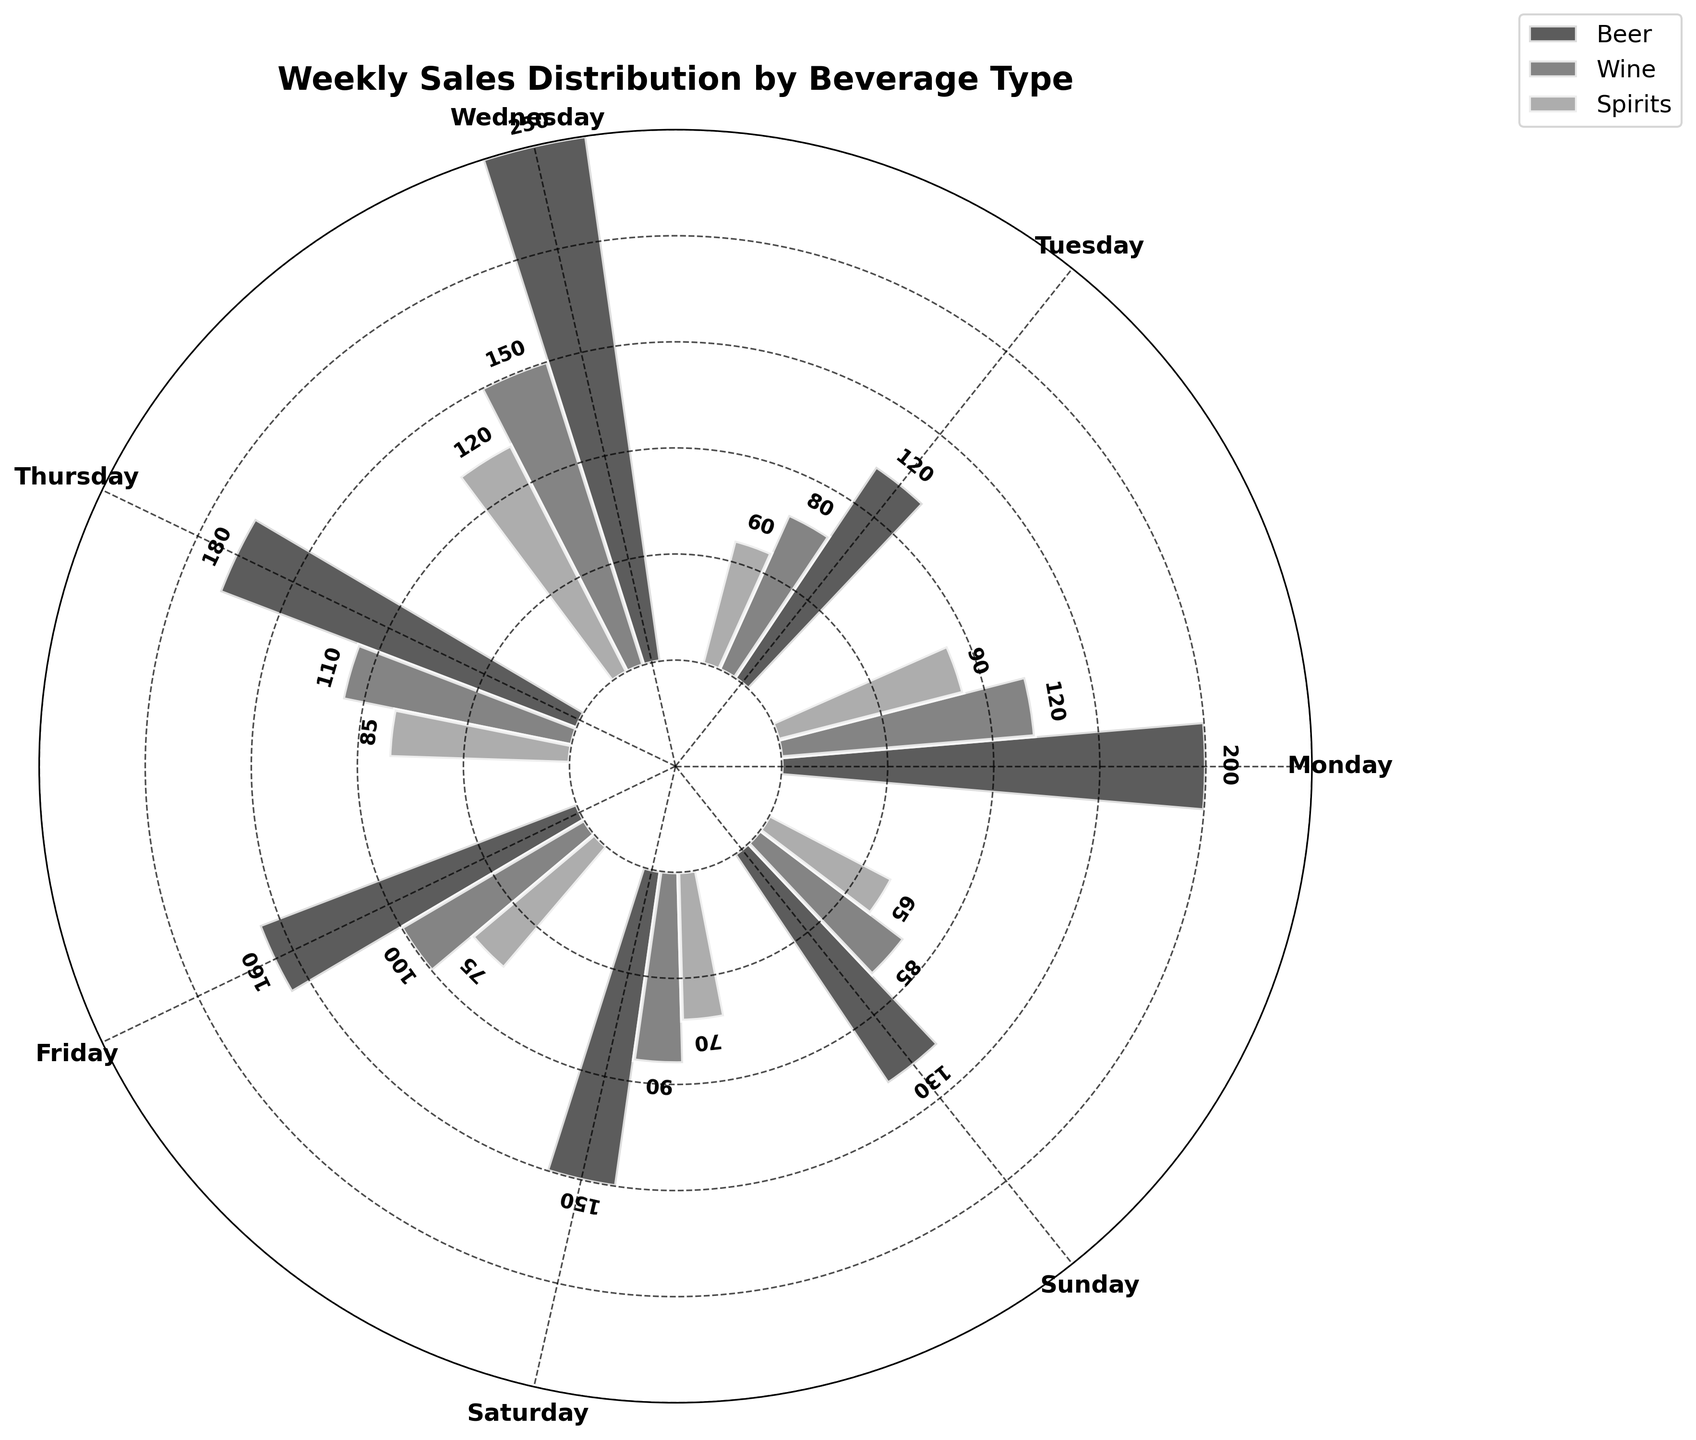What is the title of the plot? The title is typically found at the top center of the plot and provides a summary of what the plot is about. In this case, it reads "Weekly Sales Distribution by Beverage Type."
Answer: Weekly Sales Distribution by Beverage Type How many beverage types are shown in the plot? By examining the legend or observing the various bars, you can see that there are bars for Beer, Wine, and Spirits. This means there are three beverage types displayed in the plot.
Answer: Three Which beverage type has the highest sales on Saturday? To determine this, look at the bars corresponding to Saturday for each beverage type. The bar for Beer on Saturday is the tallest among the three.
Answer: Beer What is the total sales of Wine for the entire week? Sum the sales of Wine for each day of the week: 80 (Monday) + 90 (Tuesday) + 85 (Wednesday) + 100 (Thursday) + 120 (Friday) + 150 (Saturday) + 110 (Sunday). The total is 735.
Answer: 735 How much more were the Beer sales on Friday compared to Sunday? Beer sales on Friday are 200, and on Sunday they are 180. The difference is calculated as 200 - 180, which equals 20.
Answer: 20 What's the average sales for Spirits over the week? Add the sales for Spirits for each day: 60 (Monday) + 70 (Tuesday) + 65 (Wednesday) + 75 (Thursday) + 90 (Friday) + 120 (Saturday) + 85 (Sunday). The total is 565. Divide by the number of days (7) to get the average: 565 / 7.
Answer: 80.7 On which day do Beer sales peak, and what is the sales value? The tallest bar for Beer is on Saturday with a sales value of 250.
Answer: Saturday and 250 Compare the sales of Beer on Tuesday to the sales of Wine on Thursday. Which is higher? Beer sales on Tuesday are 150, while Wine sales on Thursday are 100. Beer sales on Tuesday are higher.
Answer: Beer What is the minimum sales value for Spirits during the week, and on which day does it occur? The lowest bar for Spirits is on Monday with a sales value of 60.
Answer: Monday and 60 List the sales value for all beverage types on Friday. For Friday, Beer sales are 200, Wine sales are 120, and Spirits sales are 90.
Answer: Beer: 200, Wine: 120, Spirits: 90 